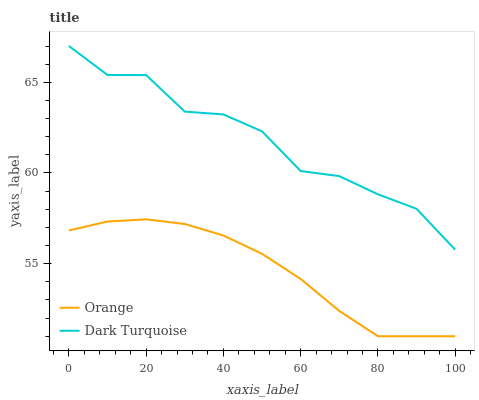Does Orange have the minimum area under the curve?
Answer yes or no. Yes. Does Dark Turquoise have the maximum area under the curve?
Answer yes or no. Yes. Does Dark Turquoise have the minimum area under the curve?
Answer yes or no. No. Is Orange the smoothest?
Answer yes or no. Yes. Is Dark Turquoise the roughest?
Answer yes or no. Yes. Is Dark Turquoise the smoothest?
Answer yes or no. No. Does Orange have the lowest value?
Answer yes or no. Yes. Does Dark Turquoise have the lowest value?
Answer yes or no. No. Does Dark Turquoise have the highest value?
Answer yes or no. Yes. Is Orange less than Dark Turquoise?
Answer yes or no. Yes. Is Dark Turquoise greater than Orange?
Answer yes or no. Yes. Does Orange intersect Dark Turquoise?
Answer yes or no. No. 